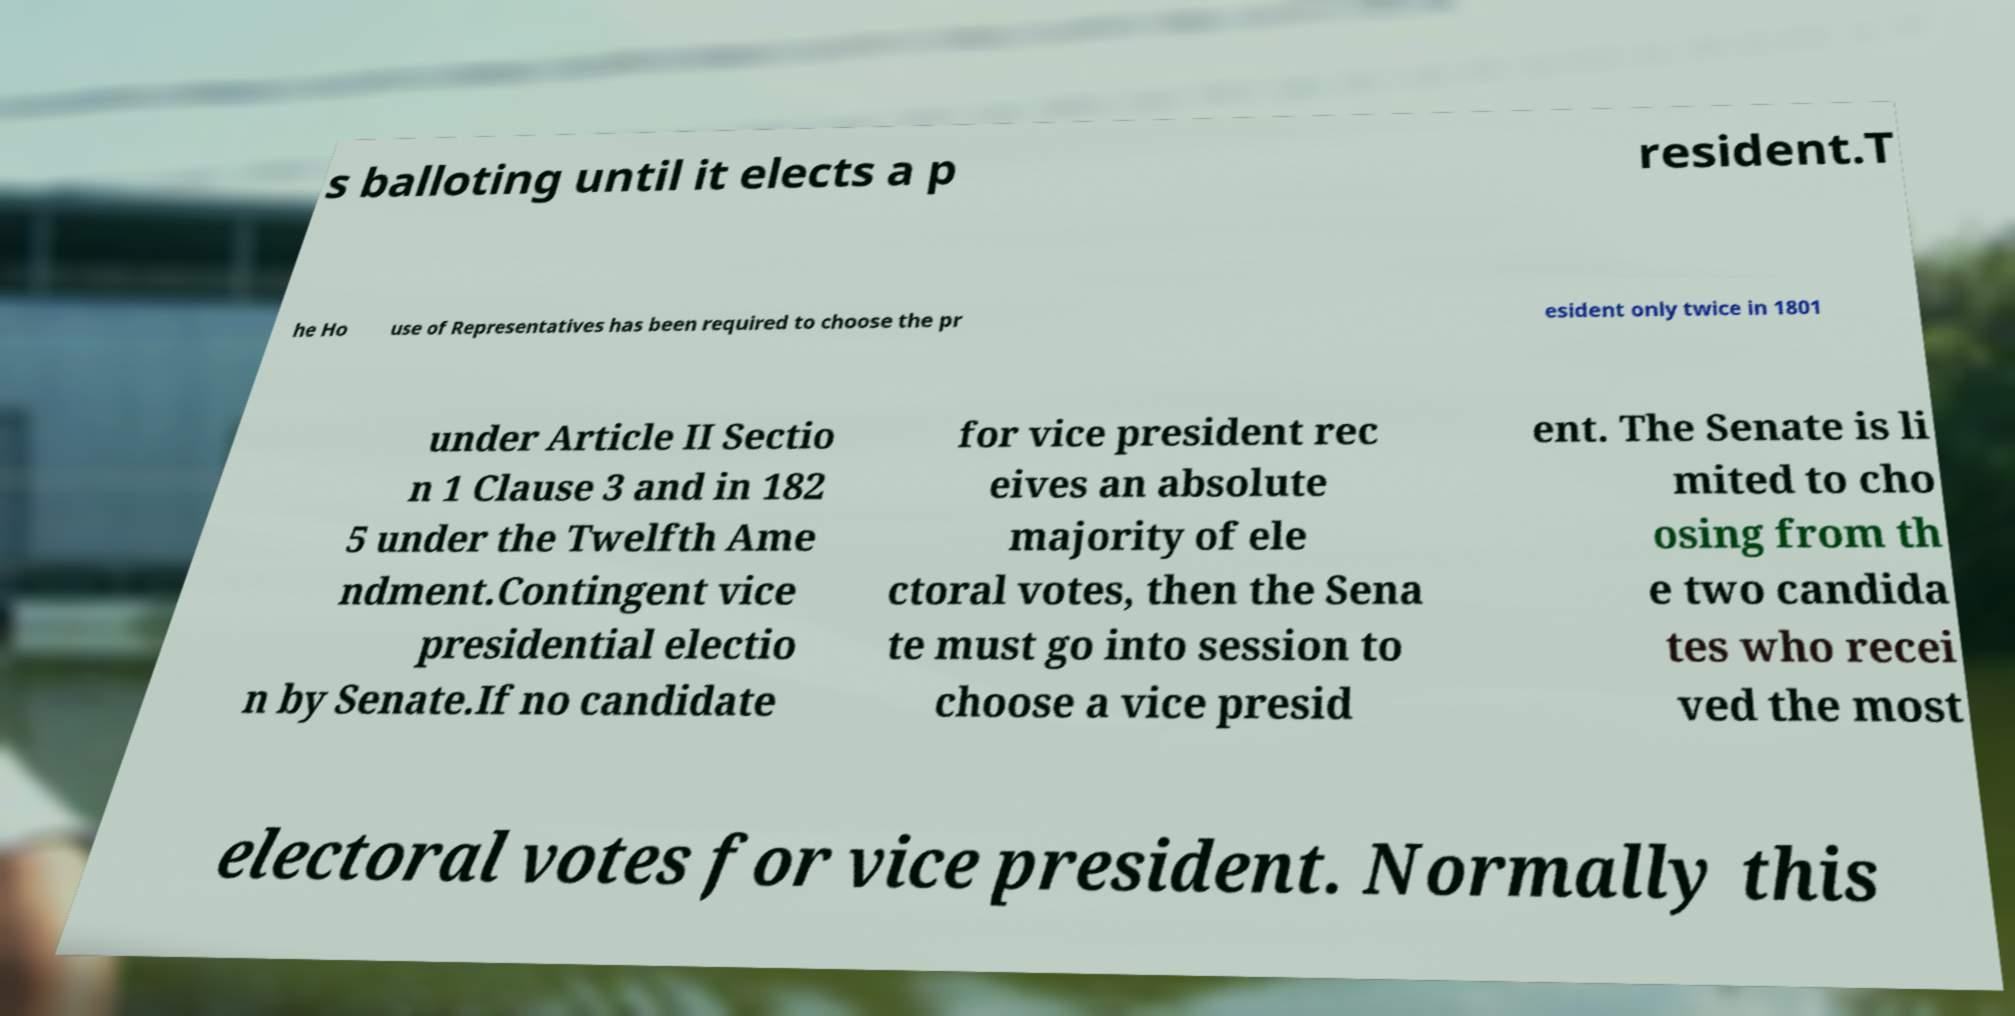There's text embedded in this image that I need extracted. Can you transcribe it verbatim? s balloting until it elects a p resident.T he Ho use of Representatives has been required to choose the pr esident only twice in 1801 under Article II Sectio n 1 Clause 3 and in 182 5 under the Twelfth Ame ndment.Contingent vice presidential electio n by Senate.If no candidate for vice president rec eives an absolute majority of ele ctoral votes, then the Sena te must go into session to choose a vice presid ent. The Senate is li mited to cho osing from th e two candida tes who recei ved the most electoral votes for vice president. Normally this 